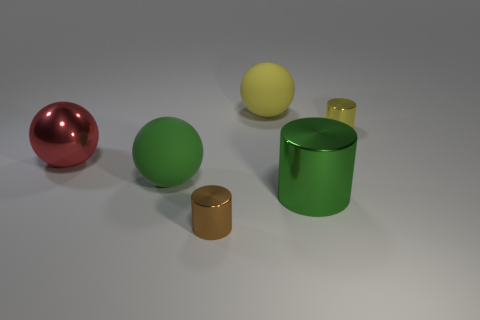What is the material of the yellow thing that is behind the tiny shiny cylinder that is behind the large green metallic object?
Make the answer very short. Rubber. How many other things are there of the same shape as the small brown metal object?
Keep it short and to the point. 2. Do the small thing that is behind the red sphere and the yellow thing that is left of the green metal thing have the same shape?
Offer a very short reply. No. Is there any other thing that has the same material as the small yellow cylinder?
Ensure brevity in your answer.  Yes. What is the material of the big red object?
Provide a short and direct response. Metal. What is the tiny object right of the tiny brown metallic cylinder made of?
Your answer should be very brief. Metal. Are there any other things that are the same color as the large shiny cylinder?
Provide a succinct answer. Yes. There is a red object that is made of the same material as the big cylinder; what is its size?
Your answer should be very brief. Large. What number of big things are either red shiny balls or metallic things?
Your answer should be very brief. 2. There is a matte sphere that is to the left of the thing behind the small cylinder right of the large yellow rubber ball; what size is it?
Make the answer very short. Large. 